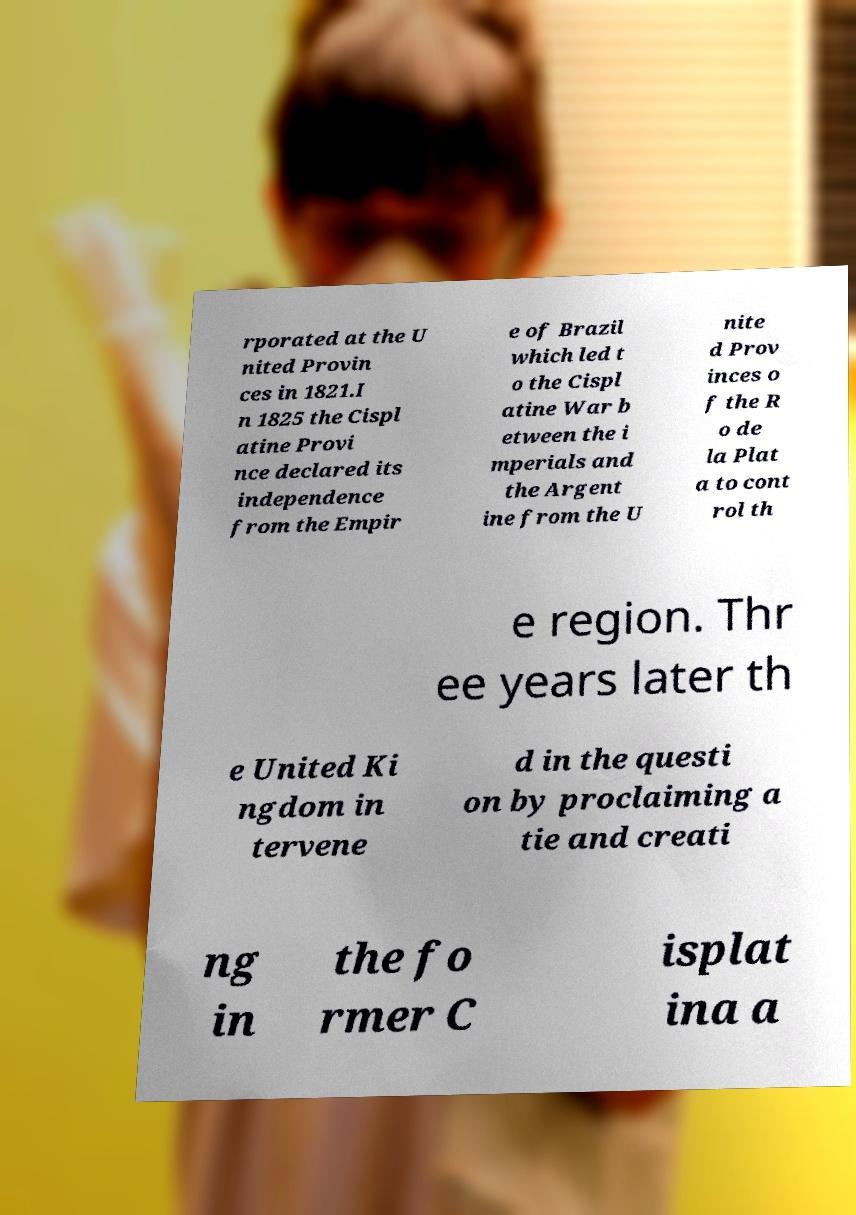There's text embedded in this image that I need extracted. Can you transcribe it verbatim? rporated at the U nited Provin ces in 1821.I n 1825 the Cispl atine Provi nce declared its independence from the Empir e of Brazil which led t o the Cispl atine War b etween the i mperials and the Argent ine from the U nite d Prov inces o f the R o de la Plat a to cont rol th e region. Thr ee years later th e United Ki ngdom in tervene d in the questi on by proclaiming a tie and creati ng in the fo rmer C isplat ina a 